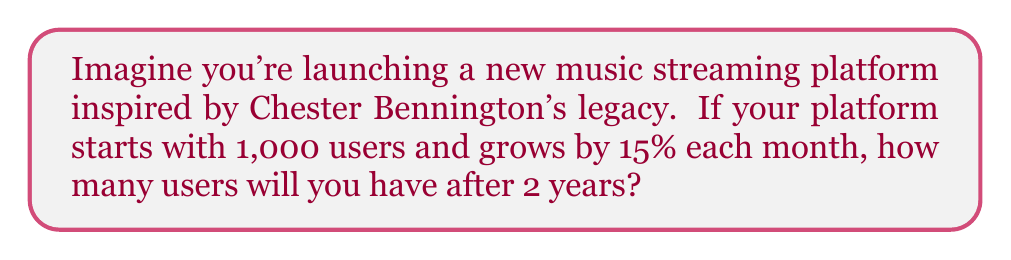Could you help me with this problem? Let's approach this step-by-step:

1) We start with an initial number of users: $N_0 = 1,000$

2) The growth rate is 15% per month, so $r = 0.15$

3) We want to find the number of users after 2 years, which is 24 months. So, $t = 24$

4) The exponential growth formula is:

   $N(t) = N_0 \cdot (1 + r)^t$

5) Plugging in our values:

   $N(24) = 1,000 \cdot (1 + 0.15)^{24}$

6) Simplify:
   
   $N(24) = 1,000 \cdot (1.15)^{24}$

7) Use a calculator to evaluate:

   $N(24) = 1,000 \cdot 31.772$
   
   $N(24) = 31,772$

Therefore, after 2 years, your streaming platform inspired by Chester Bennington would have approximately 31,772 users.
Answer: 31,772 users 